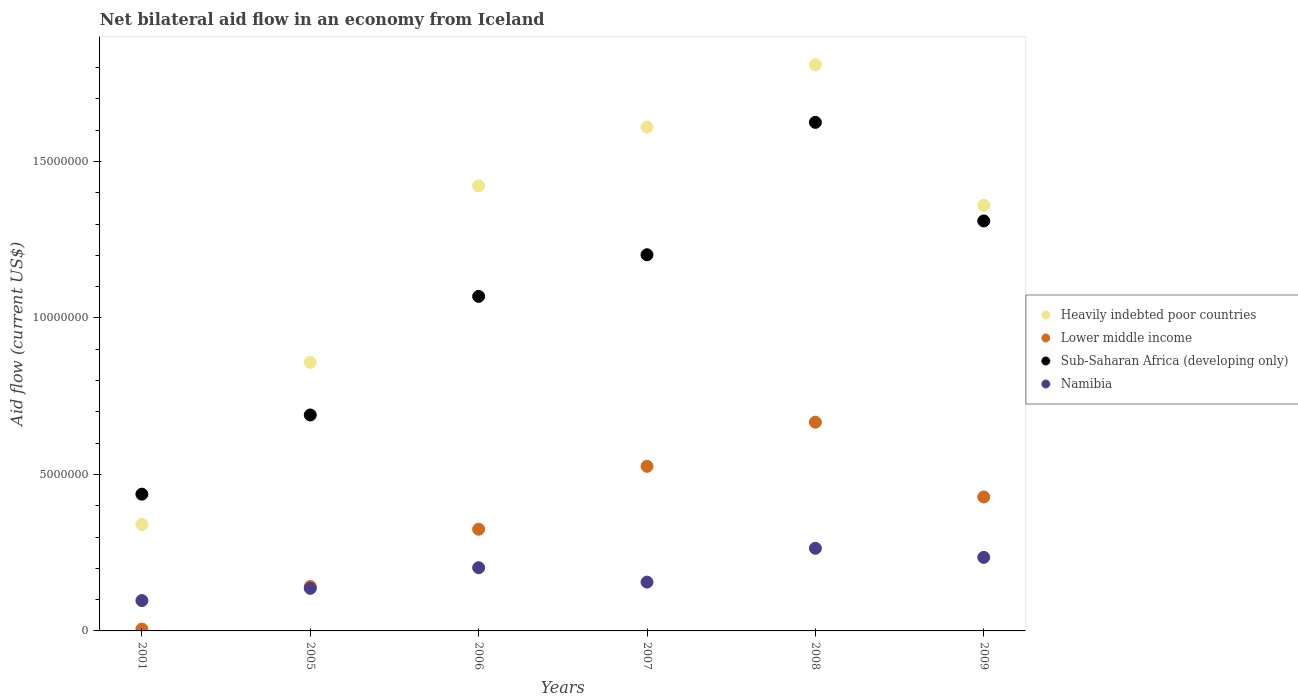What is the net bilateral aid flow in Heavily indebted poor countries in 2005?
Give a very brief answer. 8.58e+06. Across all years, what is the maximum net bilateral aid flow in Sub-Saharan Africa (developing only)?
Your answer should be compact. 1.62e+07. Across all years, what is the minimum net bilateral aid flow in Heavily indebted poor countries?
Your response must be concise. 3.40e+06. In which year was the net bilateral aid flow in Sub-Saharan Africa (developing only) minimum?
Your response must be concise. 2001. What is the total net bilateral aid flow in Lower middle income in the graph?
Provide a succinct answer. 2.09e+07. What is the difference between the net bilateral aid flow in Namibia in 2005 and that in 2008?
Provide a short and direct response. -1.28e+06. What is the difference between the net bilateral aid flow in Lower middle income in 2005 and the net bilateral aid flow in Heavily indebted poor countries in 2009?
Ensure brevity in your answer.  -1.22e+07. What is the average net bilateral aid flow in Heavily indebted poor countries per year?
Your answer should be very brief. 1.23e+07. In the year 2001, what is the difference between the net bilateral aid flow in Heavily indebted poor countries and net bilateral aid flow in Lower middle income?
Make the answer very short. 3.34e+06. What is the ratio of the net bilateral aid flow in Heavily indebted poor countries in 2001 to that in 2008?
Ensure brevity in your answer.  0.19. Is the difference between the net bilateral aid flow in Heavily indebted poor countries in 2005 and 2009 greater than the difference between the net bilateral aid flow in Lower middle income in 2005 and 2009?
Ensure brevity in your answer.  No. What is the difference between the highest and the second highest net bilateral aid flow in Lower middle income?
Offer a very short reply. 1.41e+06. What is the difference between the highest and the lowest net bilateral aid flow in Sub-Saharan Africa (developing only)?
Keep it short and to the point. 1.19e+07. In how many years, is the net bilateral aid flow in Heavily indebted poor countries greater than the average net bilateral aid flow in Heavily indebted poor countries taken over all years?
Give a very brief answer. 4. Is it the case that in every year, the sum of the net bilateral aid flow in Namibia and net bilateral aid flow in Lower middle income  is greater than the net bilateral aid flow in Sub-Saharan Africa (developing only)?
Keep it short and to the point. No. Is the net bilateral aid flow in Sub-Saharan Africa (developing only) strictly less than the net bilateral aid flow in Namibia over the years?
Keep it short and to the point. No. How many years are there in the graph?
Your answer should be compact. 6. Are the values on the major ticks of Y-axis written in scientific E-notation?
Your response must be concise. No. Does the graph contain grids?
Offer a terse response. No. Where does the legend appear in the graph?
Provide a short and direct response. Center right. What is the title of the graph?
Your answer should be very brief. Net bilateral aid flow in an economy from Iceland. Does "Brunei Darussalam" appear as one of the legend labels in the graph?
Provide a succinct answer. No. What is the label or title of the Y-axis?
Offer a very short reply. Aid flow (current US$). What is the Aid flow (current US$) in Heavily indebted poor countries in 2001?
Provide a short and direct response. 3.40e+06. What is the Aid flow (current US$) in Sub-Saharan Africa (developing only) in 2001?
Your response must be concise. 4.37e+06. What is the Aid flow (current US$) in Namibia in 2001?
Ensure brevity in your answer.  9.70e+05. What is the Aid flow (current US$) of Heavily indebted poor countries in 2005?
Provide a short and direct response. 8.58e+06. What is the Aid flow (current US$) in Lower middle income in 2005?
Offer a terse response. 1.42e+06. What is the Aid flow (current US$) in Sub-Saharan Africa (developing only) in 2005?
Provide a succinct answer. 6.90e+06. What is the Aid flow (current US$) of Namibia in 2005?
Offer a very short reply. 1.36e+06. What is the Aid flow (current US$) in Heavily indebted poor countries in 2006?
Your answer should be compact. 1.42e+07. What is the Aid flow (current US$) in Lower middle income in 2006?
Give a very brief answer. 3.25e+06. What is the Aid flow (current US$) in Sub-Saharan Africa (developing only) in 2006?
Provide a short and direct response. 1.07e+07. What is the Aid flow (current US$) in Namibia in 2006?
Offer a very short reply. 2.02e+06. What is the Aid flow (current US$) of Heavily indebted poor countries in 2007?
Provide a short and direct response. 1.61e+07. What is the Aid flow (current US$) of Lower middle income in 2007?
Keep it short and to the point. 5.26e+06. What is the Aid flow (current US$) of Sub-Saharan Africa (developing only) in 2007?
Provide a succinct answer. 1.20e+07. What is the Aid flow (current US$) in Namibia in 2007?
Your answer should be compact. 1.56e+06. What is the Aid flow (current US$) in Heavily indebted poor countries in 2008?
Give a very brief answer. 1.81e+07. What is the Aid flow (current US$) in Lower middle income in 2008?
Your answer should be very brief. 6.67e+06. What is the Aid flow (current US$) of Sub-Saharan Africa (developing only) in 2008?
Offer a very short reply. 1.62e+07. What is the Aid flow (current US$) of Namibia in 2008?
Provide a short and direct response. 2.64e+06. What is the Aid flow (current US$) of Heavily indebted poor countries in 2009?
Offer a terse response. 1.36e+07. What is the Aid flow (current US$) of Lower middle income in 2009?
Make the answer very short. 4.28e+06. What is the Aid flow (current US$) in Sub-Saharan Africa (developing only) in 2009?
Offer a very short reply. 1.31e+07. What is the Aid flow (current US$) of Namibia in 2009?
Keep it short and to the point. 2.35e+06. Across all years, what is the maximum Aid flow (current US$) in Heavily indebted poor countries?
Ensure brevity in your answer.  1.81e+07. Across all years, what is the maximum Aid flow (current US$) of Lower middle income?
Your response must be concise. 6.67e+06. Across all years, what is the maximum Aid flow (current US$) of Sub-Saharan Africa (developing only)?
Offer a terse response. 1.62e+07. Across all years, what is the maximum Aid flow (current US$) of Namibia?
Provide a short and direct response. 2.64e+06. Across all years, what is the minimum Aid flow (current US$) of Heavily indebted poor countries?
Your response must be concise. 3.40e+06. Across all years, what is the minimum Aid flow (current US$) in Sub-Saharan Africa (developing only)?
Offer a terse response. 4.37e+06. Across all years, what is the minimum Aid flow (current US$) in Namibia?
Your answer should be compact. 9.70e+05. What is the total Aid flow (current US$) of Heavily indebted poor countries in the graph?
Your response must be concise. 7.40e+07. What is the total Aid flow (current US$) in Lower middle income in the graph?
Provide a short and direct response. 2.09e+07. What is the total Aid flow (current US$) in Sub-Saharan Africa (developing only) in the graph?
Your answer should be very brief. 6.33e+07. What is the total Aid flow (current US$) in Namibia in the graph?
Your response must be concise. 1.09e+07. What is the difference between the Aid flow (current US$) in Heavily indebted poor countries in 2001 and that in 2005?
Give a very brief answer. -5.18e+06. What is the difference between the Aid flow (current US$) of Lower middle income in 2001 and that in 2005?
Provide a short and direct response. -1.36e+06. What is the difference between the Aid flow (current US$) of Sub-Saharan Africa (developing only) in 2001 and that in 2005?
Your answer should be compact. -2.53e+06. What is the difference between the Aid flow (current US$) of Namibia in 2001 and that in 2005?
Ensure brevity in your answer.  -3.90e+05. What is the difference between the Aid flow (current US$) of Heavily indebted poor countries in 2001 and that in 2006?
Your response must be concise. -1.08e+07. What is the difference between the Aid flow (current US$) in Lower middle income in 2001 and that in 2006?
Offer a terse response. -3.19e+06. What is the difference between the Aid flow (current US$) in Sub-Saharan Africa (developing only) in 2001 and that in 2006?
Ensure brevity in your answer.  -6.32e+06. What is the difference between the Aid flow (current US$) of Namibia in 2001 and that in 2006?
Offer a terse response. -1.05e+06. What is the difference between the Aid flow (current US$) in Heavily indebted poor countries in 2001 and that in 2007?
Make the answer very short. -1.27e+07. What is the difference between the Aid flow (current US$) in Lower middle income in 2001 and that in 2007?
Offer a terse response. -5.20e+06. What is the difference between the Aid flow (current US$) of Sub-Saharan Africa (developing only) in 2001 and that in 2007?
Ensure brevity in your answer.  -7.65e+06. What is the difference between the Aid flow (current US$) of Namibia in 2001 and that in 2007?
Your answer should be very brief. -5.90e+05. What is the difference between the Aid flow (current US$) of Heavily indebted poor countries in 2001 and that in 2008?
Your response must be concise. -1.47e+07. What is the difference between the Aid flow (current US$) in Lower middle income in 2001 and that in 2008?
Your answer should be compact. -6.61e+06. What is the difference between the Aid flow (current US$) of Sub-Saharan Africa (developing only) in 2001 and that in 2008?
Provide a succinct answer. -1.19e+07. What is the difference between the Aid flow (current US$) of Namibia in 2001 and that in 2008?
Provide a succinct answer. -1.67e+06. What is the difference between the Aid flow (current US$) in Heavily indebted poor countries in 2001 and that in 2009?
Give a very brief answer. -1.02e+07. What is the difference between the Aid flow (current US$) of Lower middle income in 2001 and that in 2009?
Keep it short and to the point. -4.22e+06. What is the difference between the Aid flow (current US$) in Sub-Saharan Africa (developing only) in 2001 and that in 2009?
Your answer should be compact. -8.73e+06. What is the difference between the Aid flow (current US$) of Namibia in 2001 and that in 2009?
Provide a short and direct response. -1.38e+06. What is the difference between the Aid flow (current US$) in Heavily indebted poor countries in 2005 and that in 2006?
Provide a succinct answer. -5.64e+06. What is the difference between the Aid flow (current US$) in Lower middle income in 2005 and that in 2006?
Provide a succinct answer. -1.83e+06. What is the difference between the Aid flow (current US$) of Sub-Saharan Africa (developing only) in 2005 and that in 2006?
Keep it short and to the point. -3.79e+06. What is the difference between the Aid flow (current US$) of Namibia in 2005 and that in 2006?
Give a very brief answer. -6.60e+05. What is the difference between the Aid flow (current US$) of Heavily indebted poor countries in 2005 and that in 2007?
Your answer should be very brief. -7.52e+06. What is the difference between the Aid flow (current US$) in Lower middle income in 2005 and that in 2007?
Keep it short and to the point. -3.84e+06. What is the difference between the Aid flow (current US$) in Sub-Saharan Africa (developing only) in 2005 and that in 2007?
Give a very brief answer. -5.12e+06. What is the difference between the Aid flow (current US$) in Heavily indebted poor countries in 2005 and that in 2008?
Give a very brief answer. -9.51e+06. What is the difference between the Aid flow (current US$) of Lower middle income in 2005 and that in 2008?
Give a very brief answer. -5.25e+06. What is the difference between the Aid flow (current US$) in Sub-Saharan Africa (developing only) in 2005 and that in 2008?
Your response must be concise. -9.35e+06. What is the difference between the Aid flow (current US$) in Namibia in 2005 and that in 2008?
Your answer should be very brief. -1.28e+06. What is the difference between the Aid flow (current US$) in Heavily indebted poor countries in 2005 and that in 2009?
Give a very brief answer. -5.02e+06. What is the difference between the Aid flow (current US$) of Lower middle income in 2005 and that in 2009?
Keep it short and to the point. -2.86e+06. What is the difference between the Aid flow (current US$) of Sub-Saharan Africa (developing only) in 2005 and that in 2009?
Your answer should be very brief. -6.20e+06. What is the difference between the Aid flow (current US$) of Namibia in 2005 and that in 2009?
Your response must be concise. -9.90e+05. What is the difference between the Aid flow (current US$) of Heavily indebted poor countries in 2006 and that in 2007?
Your response must be concise. -1.88e+06. What is the difference between the Aid flow (current US$) in Lower middle income in 2006 and that in 2007?
Offer a very short reply. -2.01e+06. What is the difference between the Aid flow (current US$) of Sub-Saharan Africa (developing only) in 2006 and that in 2007?
Offer a very short reply. -1.33e+06. What is the difference between the Aid flow (current US$) of Heavily indebted poor countries in 2006 and that in 2008?
Provide a succinct answer. -3.87e+06. What is the difference between the Aid flow (current US$) of Lower middle income in 2006 and that in 2008?
Your answer should be compact. -3.42e+06. What is the difference between the Aid flow (current US$) in Sub-Saharan Africa (developing only) in 2006 and that in 2008?
Your answer should be compact. -5.56e+06. What is the difference between the Aid flow (current US$) of Namibia in 2006 and that in 2008?
Your response must be concise. -6.20e+05. What is the difference between the Aid flow (current US$) of Heavily indebted poor countries in 2006 and that in 2009?
Ensure brevity in your answer.  6.20e+05. What is the difference between the Aid flow (current US$) in Lower middle income in 2006 and that in 2009?
Give a very brief answer. -1.03e+06. What is the difference between the Aid flow (current US$) in Sub-Saharan Africa (developing only) in 2006 and that in 2009?
Your response must be concise. -2.41e+06. What is the difference between the Aid flow (current US$) in Namibia in 2006 and that in 2009?
Your response must be concise. -3.30e+05. What is the difference between the Aid flow (current US$) in Heavily indebted poor countries in 2007 and that in 2008?
Your answer should be very brief. -1.99e+06. What is the difference between the Aid flow (current US$) of Lower middle income in 2007 and that in 2008?
Your response must be concise. -1.41e+06. What is the difference between the Aid flow (current US$) of Sub-Saharan Africa (developing only) in 2007 and that in 2008?
Provide a succinct answer. -4.23e+06. What is the difference between the Aid flow (current US$) of Namibia in 2007 and that in 2008?
Your response must be concise. -1.08e+06. What is the difference between the Aid flow (current US$) of Heavily indebted poor countries in 2007 and that in 2009?
Make the answer very short. 2.50e+06. What is the difference between the Aid flow (current US$) of Lower middle income in 2007 and that in 2009?
Offer a terse response. 9.80e+05. What is the difference between the Aid flow (current US$) in Sub-Saharan Africa (developing only) in 2007 and that in 2009?
Your answer should be compact. -1.08e+06. What is the difference between the Aid flow (current US$) in Namibia in 2007 and that in 2009?
Provide a short and direct response. -7.90e+05. What is the difference between the Aid flow (current US$) of Heavily indebted poor countries in 2008 and that in 2009?
Offer a very short reply. 4.49e+06. What is the difference between the Aid flow (current US$) of Lower middle income in 2008 and that in 2009?
Provide a short and direct response. 2.39e+06. What is the difference between the Aid flow (current US$) in Sub-Saharan Africa (developing only) in 2008 and that in 2009?
Offer a terse response. 3.15e+06. What is the difference between the Aid flow (current US$) of Namibia in 2008 and that in 2009?
Your answer should be very brief. 2.90e+05. What is the difference between the Aid flow (current US$) of Heavily indebted poor countries in 2001 and the Aid flow (current US$) of Lower middle income in 2005?
Give a very brief answer. 1.98e+06. What is the difference between the Aid flow (current US$) in Heavily indebted poor countries in 2001 and the Aid flow (current US$) in Sub-Saharan Africa (developing only) in 2005?
Give a very brief answer. -3.50e+06. What is the difference between the Aid flow (current US$) of Heavily indebted poor countries in 2001 and the Aid flow (current US$) of Namibia in 2005?
Make the answer very short. 2.04e+06. What is the difference between the Aid flow (current US$) of Lower middle income in 2001 and the Aid flow (current US$) of Sub-Saharan Africa (developing only) in 2005?
Your response must be concise. -6.84e+06. What is the difference between the Aid flow (current US$) in Lower middle income in 2001 and the Aid flow (current US$) in Namibia in 2005?
Make the answer very short. -1.30e+06. What is the difference between the Aid flow (current US$) of Sub-Saharan Africa (developing only) in 2001 and the Aid flow (current US$) of Namibia in 2005?
Offer a very short reply. 3.01e+06. What is the difference between the Aid flow (current US$) in Heavily indebted poor countries in 2001 and the Aid flow (current US$) in Sub-Saharan Africa (developing only) in 2006?
Make the answer very short. -7.29e+06. What is the difference between the Aid flow (current US$) of Heavily indebted poor countries in 2001 and the Aid flow (current US$) of Namibia in 2006?
Provide a short and direct response. 1.38e+06. What is the difference between the Aid flow (current US$) of Lower middle income in 2001 and the Aid flow (current US$) of Sub-Saharan Africa (developing only) in 2006?
Make the answer very short. -1.06e+07. What is the difference between the Aid flow (current US$) in Lower middle income in 2001 and the Aid flow (current US$) in Namibia in 2006?
Provide a short and direct response. -1.96e+06. What is the difference between the Aid flow (current US$) of Sub-Saharan Africa (developing only) in 2001 and the Aid flow (current US$) of Namibia in 2006?
Give a very brief answer. 2.35e+06. What is the difference between the Aid flow (current US$) in Heavily indebted poor countries in 2001 and the Aid flow (current US$) in Lower middle income in 2007?
Give a very brief answer. -1.86e+06. What is the difference between the Aid flow (current US$) in Heavily indebted poor countries in 2001 and the Aid flow (current US$) in Sub-Saharan Africa (developing only) in 2007?
Your answer should be compact. -8.62e+06. What is the difference between the Aid flow (current US$) of Heavily indebted poor countries in 2001 and the Aid flow (current US$) of Namibia in 2007?
Keep it short and to the point. 1.84e+06. What is the difference between the Aid flow (current US$) in Lower middle income in 2001 and the Aid flow (current US$) in Sub-Saharan Africa (developing only) in 2007?
Provide a short and direct response. -1.20e+07. What is the difference between the Aid flow (current US$) in Lower middle income in 2001 and the Aid flow (current US$) in Namibia in 2007?
Provide a short and direct response. -1.50e+06. What is the difference between the Aid flow (current US$) in Sub-Saharan Africa (developing only) in 2001 and the Aid flow (current US$) in Namibia in 2007?
Your response must be concise. 2.81e+06. What is the difference between the Aid flow (current US$) in Heavily indebted poor countries in 2001 and the Aid flow (current US$) in Lower middle income in 2008?
Give a very brief answer. -3.27e+06. What is the difference between the Aid flow (current US$) of Heavily indebted poor countries in 2001 and the Aid flow (current US$) of Sub-Saharan Africa (developing only) in 2008?
Provide a short and direct response. -1.28e+07. What is the difference between the Aid flow (current US$) of Heavily indebted poor countries in 2001 and the Aid flow (current US$) of Namibia in 2008?
Offer a terse response. 7.60e+05. What is the difference between the Aid flow (current US$) in Lower middle income in 2001 and the Aid flow (current US$) in Sub-Saharan Africa (developing only) in 2008?
Ensure brevity in your answer.  -1.62e+07. What is the difference between the Aid flow (current US$) in Lower middle income in 2001 and the Aid flow (current US$) in Namibia in 2008?
Your answer should be compact. -2.58e+06. What is the difference between the Aid flow (current US$) in Sub-Saharan Africa (developing only) in 2001 and the Aid flow (current US$) in Namibia in 2008?
Give a very brief answer. 1.73e+06. What is the difference between the Aid flow (current US$) in Heavily indebted poor countries in 2001 and the Aid flow (current US$) in Lower middle income in 2009?
Offer a terse response. -8.80e+05. What is the difference between the Aid flow (current US$) in Heavily indebted poor countries in 2001 and the Aid flow (current US$) in Sub-Saharan Africa (developing only) in 2009?
Provide a short and direct response. -9.70e+06. What is the difference between the Aid flow (current US$) of Heavily indebted poor countries in 2001 and the Aid flow (current US$) of Namibia in 2009?
Offer a terse response. 1.05e+06. What is the difference between the Aid flow (current US$) of Lower middle income in 2001 and the Aid flow (current US$) of Sub-Saharan Africa (developing only) in 2009?
Ensure brevity in your answer.  -1.30e+07. What is the difference between the Aid flow (current US$) of Lower middle income in 2001 and the Aid flow (current US$) of Namibia in 2009?
Your answer should be very brief. -2.29e+06. What is the difference between the Aid flow (current US$) of Sub-Saharan Africa (developing only) in 2001 and the Aid flow (current US$) of Namibia in 2009?
Your answer should be compact. 2.02e+06. What is the difference between the Aid flow (current US$) of Heavily indebted poor countries in 2005 and the Aid flow (current US$) of Lower middle income in 2006?
Your answer should be compact. 5.33e+06. What is the difference between the Aid flow (current US$) in Heavily indebted poor countries in 2005 and the Aid flow (current US$) in Sub-Saharan Africa (developing only) in 2006?
Ensure brevity in your answer.  -2.11e+06. What is the difference between the Aid flow (current US$) in Heavily indebted poor countries in 2005 and the Aid flow (current US$) in Namibia in 2006?
Provide a succinct answer. 6.56e+06. What is the difference between the Aid flow (current US$) of Lower middle income in 2005 and the Aid flow (current US$) of Sub-Saharan Africa (developing only) in 2006?
Keep it short and to the point. -9.27e+06. What is the difference between the Aid flow (current US$) in Lower middle income in 2005 and the Aid flow (current US$) in Namibia in 2006?
Offer a terse response. -6.00e+05. What is the difference between the Aid flow (current US$) in Sub-Saharan Africa (developing only) in 2005 and the Aid flow (current US$) in Namibia in 2006?
Ensure brevity in your answer.  4.88e+06. What is the difference between the Aid flow (current US$) of Heavily indebted poor countries in 2005 and the Aid flow (current US$) of Lower middle income in 2007?
Your answer should be compact. 3.32e+06. What is the difference between the Aid flow (current US$) of Heavily indebted poor countries in 2005 and the Aid flow (current US$) of Sub-Saharan Africa (developing only) in 2007?
Keep it short and to the point. -3.44e+06. What is the difference between the Aid flow (current US$) of Heavily indebted poor countries in 2005 and the Aid flow (current US$) of Namibia in 2007?
Keep it short and to the point. 7.02e+06. What is the difference between the Aid flow (current US$) in Lower middle income in 2005 and the Aid flow (current US$) in Sub-Saharan Africa (developing only) in 2007?
Provide a short and direct response. -1.06e+07. What is the difference between the Aid flow (current US$) of Sub-Saharan Africa (developing only) in 2005 and the Aid flow (current US$) of Namibia in 2007?
Your answer should be compact. 5.34e+06. What is the difference between the Aid flow (current US$) of Heavily indebted poor countries in 2005 and the Aid flow (current US$) of Lower middle income in 2008?
Your answer should be compact. 1.91e+06. What is the difference between the Aid flow (current US$) of Heavily indebted poor countries in 2005 and the Aid flow (current US$) of Sub-Saharan Africa (developing only) in 2008?
Provide a short and direct response. -7.67e+06. What is the difference between the Aid flow (current US$) of Heavily indebted poor countries in 2005 and the Aid flow (current US$) of Namibia in 2008?
Give a very brief answer. 5.94e+06. What is the difference between the Aid flow (current US$) of Lower middle income in 2005 and the Aid flow (current US$) of Sub-Saharan Africa (developing only) in 2008?
Keep it short and to the point. -1.48e+07. What is the difference between the Aid flow (current US$) in Lower middle income in 2005 and the Aid flow (current US$) in Namibia in 2008?
Provide a succinct answer. -1.22e+06. What is the difference between the Aid flow (current US$) of Sub-Saharan Africa (developing only) in 2005 and the Aid flow (current US$) of Namibia in 2008?
Give a very brief answer. 4.26e+06. What is the difference between the Aid flow (current US$) of Heavily indebted poor countries in 2005 and the Aid flow (current US$) of Lower middle income in 2009?
Make the answer very short. 4.30e+06. What is the difference between the Aid flow (current US$) of Heavily indebted poor countries in 2005 and the Aid flow (current US$) of Sub-Saharan Africa (developing only) in 2009?
Your answer should be compact. -4.52e+06. What is the difference between the Aid flow (current US$) of Heavily indebted poor countries in 2005 and the Aid flow (current US$) of Namibia in 2009?
Offer a terse response. 6.23e+06. What is the difference between the Aid flow (current US$) in Lower middle income in 2005 and the Aid flow (current US$) in Sub-Saharan Africa (developing only) in 2009?
Offer a terse response. -1.17e+07. What is the difference between the Aid flow (current US$) of Lower middle income in 2005 and the Aid flow (current US$) of Namibia in 2009?
Offer a very short reply. -9.30e+05. What is the difference between the Aid flow (current US$) in Sub-Saharan Africa (developing only) in 2005 and the Aid flow (current US$) in Namibia in 2009?
Offer a terse response. 4.55e+06. What is the difference between the Aid flow (current US$) in Heavily indebted poor countries in 2006 and the Aid flow (current US$) in Lower middle income in 2007?
Keep it short and to the point. 8.96e+06. What is the difference between the Aid flow (current US$) in Heavily indebted poor countries in 2006 and the Aid flow (current US$) in Sub-Saharan Africa (developing only) in 2007?
Make the answer very short. 2.20e+06. What is the difference between the Aid flow (current US$) of Heavily indebted poor countries in 2006 and the Aid flow (current US$) of Namibia in 2007?
Offer a terse response. 1.27e+07. What is the difference between the Aid flow (current US$) of Lower middle income in 2006 and the Aid flow (current US$) of Sub-Saharan Africa (developing only) in 2007?
Provide a short and direct response. -8.77e+06. What is the difference between the Aid flow (current US$) in Lower middle income in 2006 and the Aid flow (current US$) in Namibia in 2007?
Offer a terse response. 1.69e+06. What is the difference between the Aid flow (current US$) of Sub-Saharan Africa (developing only) in 2006 and the Aid flow (current US$) of Namibia in 2007?
Your response must be concise. 9.13e+06. What is the difference between the Aid flow (current US$) of Heavily indebted poor countries in 2006 and the Aid flow (current US$) of Lower middle income in 2008?
Provide a short and direct response. 7.55e+06. What is the difference between the Aid flow (current US$) in Heavily indebted poor countries in 2006 and the Aid flow (current US$) in Sub-Saharan Africa (developing only) in 2008?
Provide a short and direct response. -2.03e+06. What is the difference between the Aid flow (current US$) of Heavily indebted poor countries in 2006 and the Aid flow (current US$) of Namibia in 2008?
Provide a short and direct response. 1.16e+07. What is the difference between the Aid flow (current US$) in Lower middle income in 2006 and the Aid flow (current US$) in Sub-Saharan Africa (developing only) in 2008?
Keep it short and to the point. -1.30e+07. What is the difference between the Aid flow (current US$) in Sub-Saharan Africa (developing only) in 2006 and the Aid flow (current US$) in Namibia in 2008?
Provide a succinct answer. 8.05e+06. What is the difference between the Aid flow (current US$) of Heavily indebted poor countries in 2006 and the Aid flow (current US$) of Lower middle income in 2009?
Offer a terse response. 9.94e+06. What is the difference between the Aid flow (current US$) in Heavily indebted poor countries in 2006 and the Aid flow (current US$) in Sub-Saharan Africa (developing only) in 2009?
Your response must be concise. 1.12e+06. What is the difference between the Aid flow (current US$) of Heavily indebted poor countries in 2006 and the Aid flow (current US$) of Namibia in 2009?
Your answer should be very brief. 1.19e+07. What is the difference between the Aid flow (current US$) in Lower middle income in 2006 and the Aid flow (current US$) in Sub-Saharan Africa (developing only) in 2009?
Offer a terse response. -9.85e+06. What is the difference between the Aid flow (current US$) in Sub-Saharan Africa (developing only) in 2006 and the Aid flow (current US$) in Namibia in 2009?
Keep it short and to the point. 8.34e+06. What is the difference between the Aid flow (current US$) of Heavily indebted poor countries in 2007 and the Aid flow (current US$) of Lower middle income in 2008?
Keep it short and to the point. 9.43e+06. What is the difference between the Aid flow (current US$) in Heavily indebted poor countries in 2007 and the Aid flow (current US$) in Namibia in 2008?
Provide a short and direct response. 1.35e+07. What is the difference between the Aid flow (current US$) of Lower middle income in 2007 and the Aid flow (current US$) of Sub-Saharan Africa (developing only) in 2008?
Your answer should be very brief. -1.10e+07. What is the difference between the Aid flow (current US$) of Lower middle income in 2007 and the Aid flow (current US$) of Namibia in 2008?
Give a very brief answer. 2.62e+06. What is the difference between the Aid flow (current US$) of Sub-Saharan Africa (developing only) in 2007 and the Aid flow (current US$) of Namibia in 2008?
Offer a terse response. 9.38e+06. What is the difference between the Aid flow (current US$) in Heavily indebted poor countries in 2007 and the Aid flow (current US$) in Lower middle income in 2009?
Your answer should be very brief. 1.18e+07. What is the difference between the Aid flow (current US$) of Heavily indebted poor countries in 2007 and the Aid flow (current US$) of Namibia in 2009?
Provide a succinct answer. 1.38e+07. What is the difference between the Aid flow (current US$) in Lower middle income in 2007 and the Aid flow (current US$) in Sub-Saharan Africa (developing only) in 2009?
Make the answer very short. -7.84e+06. What is the difference between the Aid flow (current US$) of Lower middle income in 2007 and the Aid flow (current US$) of Namibia in 2009?
Give a very brief answer. 2.91e+06. What is the difference between the Aid flow (current US$) of Sub-Saharan Africa (developing only) in 2007 and the Aid flow (current US$) of Namibia in 2009?
Ensure brevity in your answer.  9.67e+06. What is the difference between the Aid flow (current US$) in Heavily indebted poor countries in 2008 and the Aid flow (current US$) in Lower middle income in 2009?
Your response must be concise. 1.38e+07. What is the difference between the Aid flow (current US$) in Heavily indebted poor countries in 2008 and the Aid flow (current US$) in Sub-Saharan Africa (developing only) in 2009?
Provide a short and direct response. 4.99e+06. What is the difference between the Aid flow (current US$) of Heavily indebted poor countries in 2008 and the Aid flow (current US$) of Namibia in 2009?
Provide a succinct answer. 1.57e+07. What is the difference between the Aid flow (current US$) of Lower middle income in 2008 and the Aid flow (current US$) of Sub-Saharan Africa (developing only) in 2009?
Offer a very short reply. -6.43e+06. What is the difference between the Aid flow (current US$) in Lower middle income in 2008 and the Aid flow (current US$) in Namibia in 2009?
Keep it short and to the point. 4.32e+06. What is the difference between the Aid flow (current US$) of Sub-Saharan Africa (developing only) in 2008 and the Aid flow (current US$) of Namibia in 2009?
Offer a terse response. 1.39e+07. What is the average Aid flow (current US$) of Heavily indebted poor countries per year?
Ensure brevity in your answer.  1.23e+07. What is the average Aid flow (current US$) in Lower middle income per year?
Your answer should be very brief. 3.49e+06. What is the average Aid flow (current US$) in Sub-Saharan Africa (developing only) per year?
Offer a very short reply. 1.06e+07. What is the average Aid flow (current US$) of Namibia per year?
Your response must be concise. 1.82e+06. In the year 2001, what is the difference between the Aid flow (current US$) in Heavily indebted poor countries and Aid flow (current US$) in Lower middle income?
Your answer should be compact. 3.34e+06. In the year 2001, what is the difference between the Aid flow (current US$) of Heavily indebted poor countries and Aid flow (current US$) of Sub-Saharan Africa (developing only)?
Keep it short and to the point. -9.70e+05. In the year 2001, what is the difference between the Aid flow (current US$) of Heavily indebted poor countries and Aid flow (current US$) of Namibia?
Make the answer very short. 2.43e+06. In the year 2001, what is the difference between the Aid flow (current US$) in Lower middle income and Aid flow (current US$) in Sub-Saharan Africa (developing only)?
Your answer should be very brief. -4.31e+06. In the year 2001, what is the difference between the Aid flow (current US$) of Lower middle income and Aid flow (current US$) of Namibia?
Your response must be concise. -9.10e+05. In the year 2001, what is the difference between the Aid flow (current US$) of Sub-Saharan Africa (developing only) and Aid flow (current US$) of Namibia?
Your response must be concise. 3.40e+06. In the year 2005, what is the difference between the Aid flow (current US$) of Heavily indebted poor countries and Aid flow (current US$) of Lower middle income?
Offer a very short reply. 7.16e+06. In the year 2005, what is the difference between the Aid flow (current US$) in Heavily indebted poor countries and Aid flow (current US$) in Sub-Saharan Africa (developing only)?
Your answer should be very brief. 1.68e+06. In the year 2005, what is the difference between the Aid flow (current US$) in Heavily indebted poor countries and Aid flow (current US$) in Namibia?
Ensure brevity in your answer.  7.22e+06. In the year 2005, what is the difference between the Aid flow (current US$) of Lower middle income and Aid flow (current US$) of Sub-Saharan Africa (developing only)?
Provide a succinct answer. -5.48e+06. In the year 2005, what is the difference between the Aid flow (current US$) in Lower middle income and Aid flow (current US$) in Namibia?
Provide a short and direct response. 6.00e+04. In the year 2005, what is the difference between the Aid flow (current US$) of Sub-Saharan Africa (developing only) and Aid flow (current US$) of Namibia?
Give a very brief answer. 5.54e+06. In the year 2006, what is the difference between the Aid flow (current US$) of Heavily indebted poor countries and Aid flow (current US$) of Lower middle income?
Provide a short and direct response. 1.10e+07. In the year 2006, what is the difference between the Aid flow (current US$) of Heavily indebted poor countries and Aid flow (current US$) of Sub-Saharan Africa (developing only)?
Keep it short and to the point. 3.53e+06. In the year 2006, what is the difference between the Aid flow (current US$) in Heavily indebted poor countries and Aid flow (current US$) in Namibia?
Give a very brief answer. 1.22e+07. In the year 2006, what is the difference between the Aid flow (current US$) in Lower middle income and Aid flow (current US$) in Sub-Saharan Africa (developing only)?
Your answer should be very brief. -7.44e+06. In the year 2006, what is the difference between the Aid flow (current US$) of Lower middle income and Aid flow (current US$) of Namibia?
Make the answer very short. 1.23e+06. In the year 2006, what is the difference between the Aid flow (current US$) in Sub-Saharan Africa (developing only) and Aid flow (current US$) in Namibia?
Keep it short and to the point. 8.67e+06. In the year 2007, what is the difference between the Aid flow (current US$) of Heavily indebted poor countries and Aid flow (current US$) of Lower middle income?
Ensure brevity in your answer.  1.08e+07. In the year 2007, what is the difference between the Aid flow (current US$) in Heavily indebted poor countries and Aid flow (current US$) in Sub-Saharan Africa (developing only)?
Provide a succinct answer. 4.08e+06. In the year 2007, what is the difference between the Aid flow (current US$) in Heavily indebted poor countries and Aid flow (current US$) in Namibia?
Offer a terse response. 1.45e+07. In the year 2007, what is the difference between the Aid flow (current US$) of Lower middle income and Aid flow (current US$) of Sub-Saharan Africa (developing only)?
Ensure brevity in your answer.  -6.76e+06. In the year 2007, what is the difference between the Aid flow (current US$) in Lower middle income and Aid flow (current US$) in Namibia?
Provide a succinct answer. 3.70e+06. In the year 2007, what is the difference between the Aid flow (current US$) in Sub-Saharan Africa (developing only) and Aid flow (current US$) in Namibia?
Provide a short and direct response. 1.05e+07. In the year 2008, what is the difference between the Aid flow (current US$) of Heavily indebted poor countries and Aid flow (current US$) of Lower middle income?
Give a very brief answer. 1.14e+07. In the year 2008, what is the difference between the Aid flow (current US$) of Heavily indebted poor countries and Aid flow (current US$) of Sub-Saharan Africa (developing only)?
Give a very brief answer. 1.84e+06. In the year 2008, what is the difference between the Aid flow (current US$) in Heavily indebted poor countries and Aid flow (current US$) in Namibia?
Offer a very short reply. 1.54e+07. In the year 2008, what is the difference between the Aid flow (current US$) of Lower middle income and Aid flow (current US$) of Sub-Saharan Africa (developing only)?
Provide a succinct answer. -9.58e+06. In the year 2008, what is the difference between the Aid flow (current US$) of Lower middle income and Aid flow (current US$) of Namibia?
Your answer should be compact. 4.03e+06. In the year 2008, what is the difference between the Aid flow (current US$) in Sub-Saharan Africa (developing only) and Aid flow (current US$) in Namibia?
Your answer should be compact. 1.36e+07. In the year 2009, what is the difference between the Aid flow (current US$) in Heavily indebted poor countries and Aid flow (current US$) in Lower middle income?
Your answer should be compact. 9.32e+06. In the year 2009, what is the difference between the Aid flow (current US$) of Heavily indebted poor countries and Aid flow (current US$) of Sub-Saharan Africa (developing only)?
Make the answer very short. 5.00e+05. In the year 2009, what is the difference between the Aid flow (current US$) in Heavily indebted poor countries and Aid flow (current US$) in Namibia?
Offer a terse response. 1.12e+07. In the year 2009, what is the difference between the Aid flow (current US$) in Lower middle income and Aid flow (current US$) in Sub-Saharan Africa (developing only)?
Provide a short and direct response. -8.82e+06. In the year 2009, what is the difference between the Aid flow (current US$) of Lower middle income and Aid flow (current US$) of Namibia?
Offer a terse response. 1.93e+06. In the year 2009, what is the difference between the Aid flow (current US$) in Sub-Saharan Africa (developing only) and Aid flow (current US$) in Namibia?
Offer a very short reply. 1.08e+07. What is the ratio of the Aid flow (current US$) in Heavily indebted poor countries in 2001 to that in 2005?
Keep it short and to the point. 0.4. What is the ratio of the Aid flow (current US$) in Lower middle income in 2001 to that in 2005?
Your response must be concise. 0.04. What is the ratio of the Aid flow (current US$) in Sub-Saharan Africa (developing only) in 2001 to that in 2005?
Keep it short and to the point. 0.63. What is the ratio of the Aid flow (current US$) of Namibia in 2001 to that in 2005?
Ensure brevity in your answer.  0.71. What is the ratio of the Aid flow (current US$) of Heavily indebted poor countries in 2001 to that in 2006?
Ensure brevity in your answer.  0.24. What is the ratio of the Aid flow (current US$) in Lower middle income in 2001 to that in 2006?
Provide a short and direct response. 0.02. What is the ratio of the Aid flow (current US$) in Sub-Saharan Africa (developing only) in 2001 to that in 2006?
Ensure brevity in your answer.  0.41. What is the ratio of the Aid flow (current US$) in Namibia in 2001 to that in 2006?
Keep it short and to the point. 0.48. What is the ratio of the Aid flow (current US$) in Heavily indebted poor countries in 2001 to that in 2007?
Provide a short and direct response. 0.21. What is the ratio of the Aid flow (current US$) of Lower middle income in 2001 to that in 2007?
Your answer should be compact. 0.01. What is the ratio of the Aid flow (current US$) of Sub-Saharan Africa (developing only) in 2001 to that in 2007?
Give a very brief answer. 0.36. What is the ratio of the Aid flow (current US$) in Namibia in 2001 to that in 2007?
Your answer should be very brief. 0.62. What is the ratio of the Aid flow (current US$) in Heavily indebted poor countries in 2001 to that in 2008?
Provide a succinct answer. 0.19. What is the ratio of the Aid flow (current US$) in Lower middle income in 2001 to that in 2008?
Your answer should be very brief. 0.01. What is the ratio of the Aid flow (current US$) of Sub-Saharan Africa (developing only) in 2001 to that in 2008?
Offer a very short reply. 0.27. What is the ratio of the Aid flow (current US$) of Namibia in 2001 to that in 2008?
Ensure brevity in your answer.  0.37. What is the ratio of the Aid flow (current US$) in Heavily indebted poor countries in 2001 to that in 2009?
Provide a succinct answer. 0.25. What is the ratio of the Aid flow (current US$) in Lower middle income in 2001 to that in 2009?
Offer a very short reply. 0.01. What is the ratio of the Aid flow (current US$) in Sub-Saharan Africa (developing only) in 2001 to that in 2009?
Your answer should be compact. 0.33. What is the ratio of the Aid flow (current US$) in Namibia in 2001 to that in 2009?
Offer a terse response. 0.41. What is the ratio of the Aid flow (current US$) in Heavily indebted poor countries in 2005 to that in 2006?
Provide a short and direct response. 0.6. What is the ratio of the Aid flow (current US$) of Lower middle income in 2005 to that in 2006?
Offer a terse response. 0.44. What is the ratio of the Aid flow (current US$) of Sub-Saharan Africa (developing only) in 2005 to that in 2006?
Your response must be concise. 0.65. What is the ratio of the Aid flow (current US$) in Namibia in 2005 to that in 2006?
Provide a succinct answer. 0.67. What is the ratio of the Aid flow (current US$) in Heavily indebted poor countries in 2005 to that in 2007?
Offer a very short reply. 0.53. What is the ratio of the Aid flow (current US$) in Lower middle income in 2005 to that in 2007?
Your answer should be very brief. 0.27. What is the ratio of the Aid flow (current US$) of Sub-Saharan Africa (developing only) in 2005 to that in 2007?
Provide a short and direct response. 0.57. What is the ratio of the Aid flow (current US$) of Namibia in 2005 to that in 2007?
Keep it short and to the point. 0.87. What is the ratio of the Aid flow (current US$) of Heavily indebted poor countries in 2005 to that in 2008?
Your answer should be very brief. 0.47. What is the ratio of the Aid flow (current US$) of Lower middle income in 2005 to that in 2008?
Keep it short and to the point. 0.21. What is the ratio of the Aid flow (current US$) of Sub-Saharan Africa (developing only) in 2005 to that in 2008?
Keep it short and to the point. 0.42. What is the ratio of the Aid flow (current US$) in Namibia in 2005 to that in 2008?
Provide a succinct answer. 0.52. What is the ratio of the Aid flow (current US$) of Heavily indebted poor countries in 2005 to that in 2009?
Offer a very short reply. 0.63. What is the ratio of the Aid flow (current US$) of Lower middle income in 2005 to that in 2009?
Provide a short and direct response. 0.33. What is the ratio of the Aid flow (current US$) of Sub-Saharan Africa (developing only) in 2005 to that in 2009?
Provide a succinct answer. 0.53. What is the ratio of the Aid flow (current US$) of Namibia in 2005 to that in 2009?
Your answer should be very brief. 0.58. What is the ratio of the Aid flow (current US$) in Heavily indebted poor countries in 2006 to that in 2007?
Your response must be concise. 0.88. What is the ratio of the Aid flow (current US$) of Lower middle income in 2006 to that in 2007?
Keep it short and to the point. 0.62. What is the ratio of the Aid flow (current US$) of Sub-Saharan Africa (developing only) in 2006 to that in 2007?
Your answer should be very brief. 0.89. What is the ratio of the Aid flow (current US$) of Namibia in 2006 to that in 2007?
Your response must be concise. 1.29. What is the ratio of the Aid flow (current US$) in Heavily indebted poor countries in 2006 to that in 2008?
Provide a short and direct response. 0.79. What is the ratio of the Aid flow (current US$) in Lower middle income in 2006 to that in 2008?
Keep it short and to the point. 0.49. What is the ratio of the Aid flow (current US$) of Sub-Saharan Africa (developing only) in 2006 to that in 2008?
Provide a short and direct response. 0.66. What is the ratio of the Aid flow (current US$) of Namibia in 2006 to that in 2008?
Make the answer very short. 0.77. What is the ratio of the Aid flow (current US$) of Heavily indebted poor countries in 2006 to that in 2009?
Give a very brief answer. 1.05. What is the ratio of the Aid flow (current US$) in Lower middle income in 2006 to that in 2009?
Give a very brief answer. 0.76. What is the ratio of the Aid flow (current US$) in Sub-Saharan Africa (developing only) in 2006 to that in 2009?
Offer a very short reply. 0.82. What is the ratio of the Aid flow (current US$) of Namibia in 2006 to that in 2009?
Provide a short and direct response. 0.86. What is the ratio of the Aid flow (current US$) in Heavily indebted poor countries in 2007 to that in 2008?
Make the answer very short. 0.89. What is the ratio of the Aid flow (current US$) in Lower middle income in 2007 to that in 2008?
Offer a very short reply. 0.79. What is the ratio of the Aid flow (current US$) of Sub-Saharan Africa (developing only) in 2007 to that in 2008?
Offer a terse response. 0.74. What is the ratio of the Aid flow (current US$) in Namibia in 2007 to that in 2008?
Ensure brevity in your answer.  0.59. What is the ratio of the Aid flow (current US$) in Heavily indebted poor countries in 2007 to that in 2009?
Keep it short and to the point. 1.18. What is the ratio of the Aid flow (current US$) of Lower middle income in 2007 to that in 2009?
Make the answer very short. 1.23. What is the ratio of the Aid flow (current US$) of Sub-Saharan Africa (developing only) in 2007 to that in 2009?
Provide a succinct answer. 0.92. What is the ratio of the Aid flow (current US$) in Namibia in 2007 to that in 2009?
Make the answer very short. 0.66. What is the ratio of the Aid flow (current US$) in Heavily indebted poor countries in 2008 to that in 2009?
Provide a succinct answer. 1.33. What is the ratio of the Aid flow (current US$) of Lower middle income in 2008 to that in 2009?
Provide a succinct answer. 1.56. What is the ratio of the Aid flow (current US$) in Sub-Saharan Africa (developing only) in 2008 to that in 2009?
Your answer should be compact. 1.24. What is the ratio of the Aid flow (current US$) in Namibia in 2008 to that in 2009?
Provide a succinct answer. 1.12. What is the difference between the highest and the second highest Aid flow (current US$) in Heavily indebted poor countries?
Keep it short and to the point. 1.99e+06. What is the difference between the highest and the second highest Aid flow (current US$) of Lower middle income?
Provide a short and direct response. 1.41e+06. What is the difference between the highest and the second highest Aid flow (current US$) in Sub-Saharan Africa (developing only)?
Your response must be concise. 3.15e+06. What is the difference between the highest and the lowest Aid flow (current US$) of Heavily indebted poor countries?
Keep it short and to the point. 1.47e+07. What is the difference between the highest and the lowest Aid flow (current US$) in Lower middle income?
Provide a succinct answer. 6.61e+06. What is the difference between the highest and the lowest Aid flow (current US$) of Sub-Saharan Africa (developing only)?
Your response must be concise. 1.19e+07. What is the difference between the highest and the lowest Aid flow (current US$) of Namibia?
Your answer should be compact. 1.67e+06. 